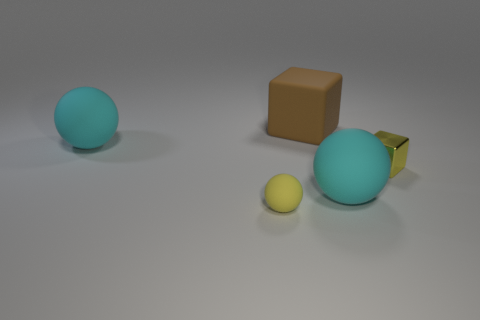Subtract all big spheres. How many spheres are left? 1 Add 3 purple blocks. How many objects exist? 8 Subtract 2 balls. How many balls are left? 1 Subtract all blocks. How many objects are left? 3 Subtract all yellow spheres. How many spheres are left? 2 Subtract all green blocks. How many purple spheres are left? 0 Subtract all large brown cubes. Subtract all big brown things. How many objects are left? 3 Add 2 big cyan rubber spheres. How many big cyan rubber spheres are left? 4 Add 4 big cyan objects. How many big cyan objects exist? 6 Subtract 0 red balls. How many objects are left? 5 